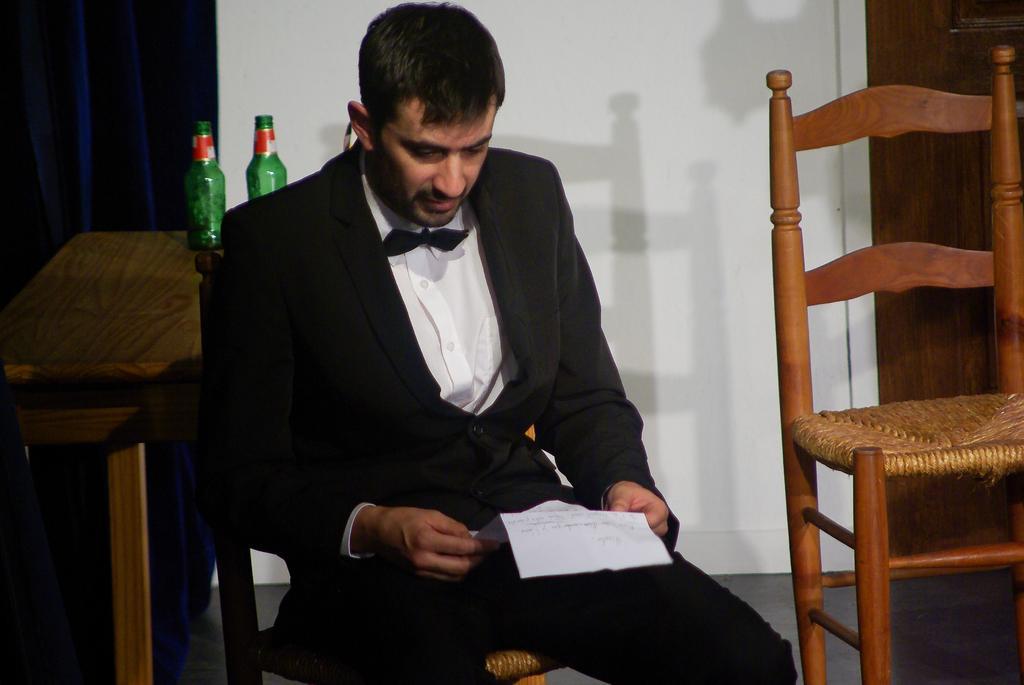Describe this image in one or two sentences. A person in black suit is sitting on a chair and holds paper. On this table there are bottles. Curtain is in blue color. Beside this person there is an another chair. 